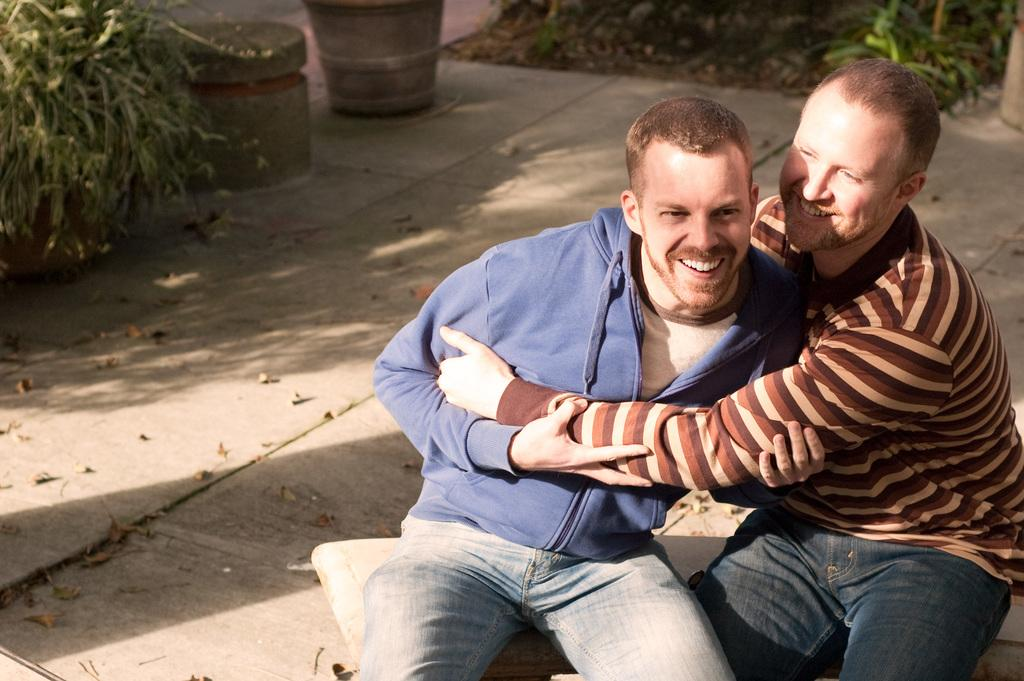How many people are in the image? There are two men in the image. What are the men doing in the image? The men are sitting and smiling. What can be seen on the left side of the image? There are plants on the left side of the image. What can be seen on the right side of the image? There are plants on the right side of the image. What is visible at the bottom of the image? There are leaves visible at the bottom of the image. What type of experience does the mother have in the image? There is no mention of a mother or any experience in the image; it features two men sitting and smiling with plants on both sides. 